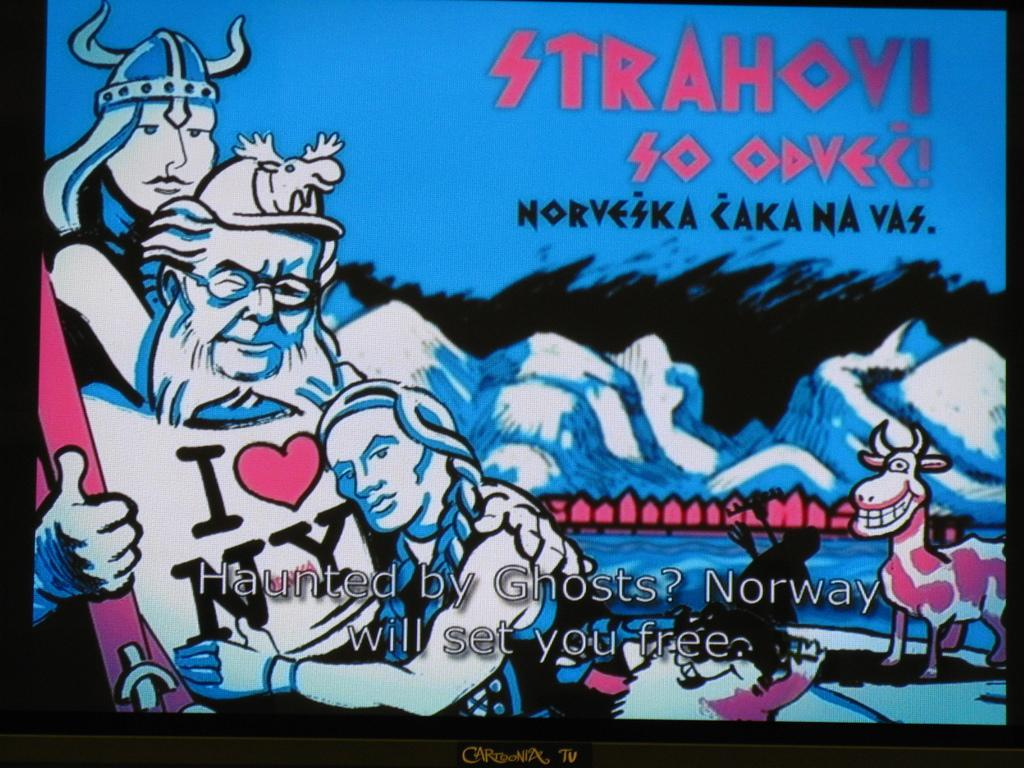<image>
Write a terse but informative summary of the picture. sign post of stahovi so odvec people hugging 